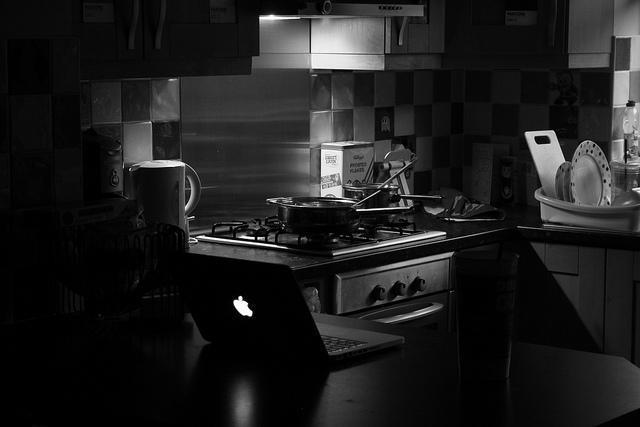How many knobs are on the stove?
Give a very brief answer. 3. 